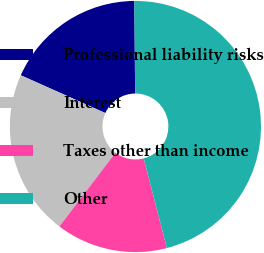<chart> <loc_0><loc_0><loc_500><loc_500><pie_chart><fcel>Professional liability risks<fcel>Interest<fcel>Taxes other than income<fcel>Other<nl><fcel>18.17%<fcel>21.34%<fcel>14.38%<fcel>46.1%<nl></chart> 